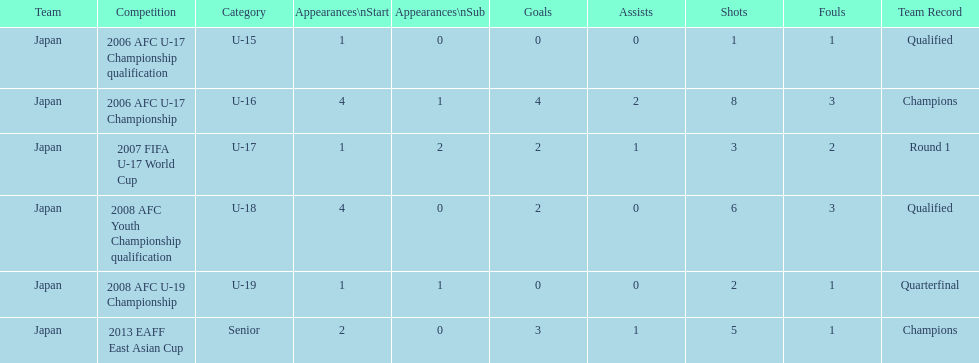Can you give me this table as a dict? {'header': ['Team', 'Competition', 'Category', 'Appearances\\nStart', 'Appearances\\nSub', 'Goals', 'Assists', 'Shots', 'Fouls', 'Team Record'], 'rows': [['Japan', '2006 AFC U-17 Championship qualification', 'U-15', '1', '0', '0', '0', '1', '1', 'Qualified'], ['Japan', '2006 AFC U-17 Championship', 'U-16', '4', '1', '4', '2', '8', '3', 'Champions'], ['Japan', '2007 FIFA U-17 World Cup', 'U-17', '1', '2', '2', '1', '3', '2', 'Round 1'], ['Japan', '2008 AFC Youth Championship qualification', 'U-18', '4', '0', '2', '0', '6', '3', 'Qualified'], ['Japan', '2008 AFC U-19 Championship', 'U-19', '1', '1', '0', '0', '2', '1', 'Quarterfinal'], ['Japan', '2013 EAFF East Asian Cup', 'Senior', '2', '0', '3', '1', '5', '1', 'Champions']]} Name the earliest competition to have a sub. 2006 AFC U-17 Championship. 